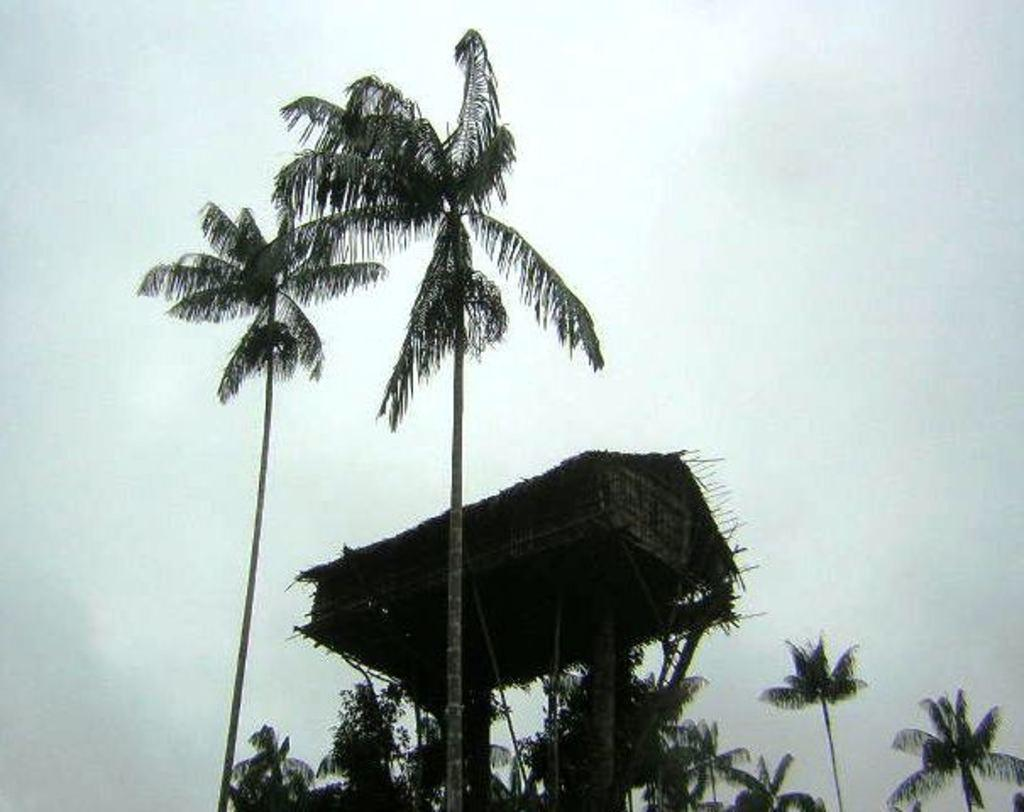What type of vegetation can be seen in the image? There are trees in the image. Is there any structure built on the trees in the image? Yes, there is a tree house in the image. What type of bike is being used for the selection process in the image? There is no bike or selection process present in the image; it features trees and a tree house. 